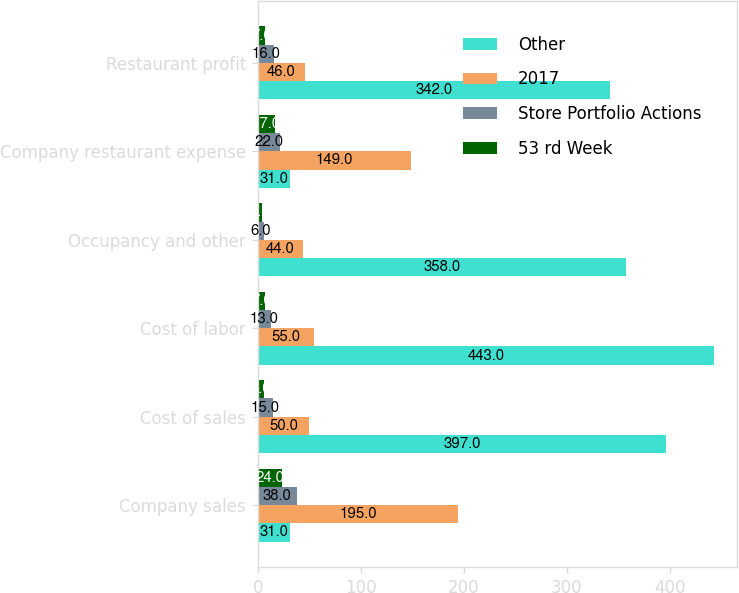<chart> <loc_0><loc_0><loc_500><loc_500><stacked_bar_chart><ecel><fcel>Company sales<fcel>Cost of sales<fcel>Cost of labor<fcel>Occupancy and other<fcel>Company restaurant expense<fcel>Restaurant profit<nl><fcel>Other<fcel>31<fcel>397<fcel>443<fcel>358<fcel>31<fcel>342<nl><fcel>2017<fcel>195<fcel>50<fcel>55<fcel>44<fcel>149<fcel>46<nl><fcel>Store Portfolio Actions<fcel>38<fcel>15<fcel>13<fcel>6<fcel>22<fcel>16<nl><fcel>53 rd Week<fcel>24<fcel>6<fcel>7<fcel>4<fcel>17<fcel>7<nl></chart> 